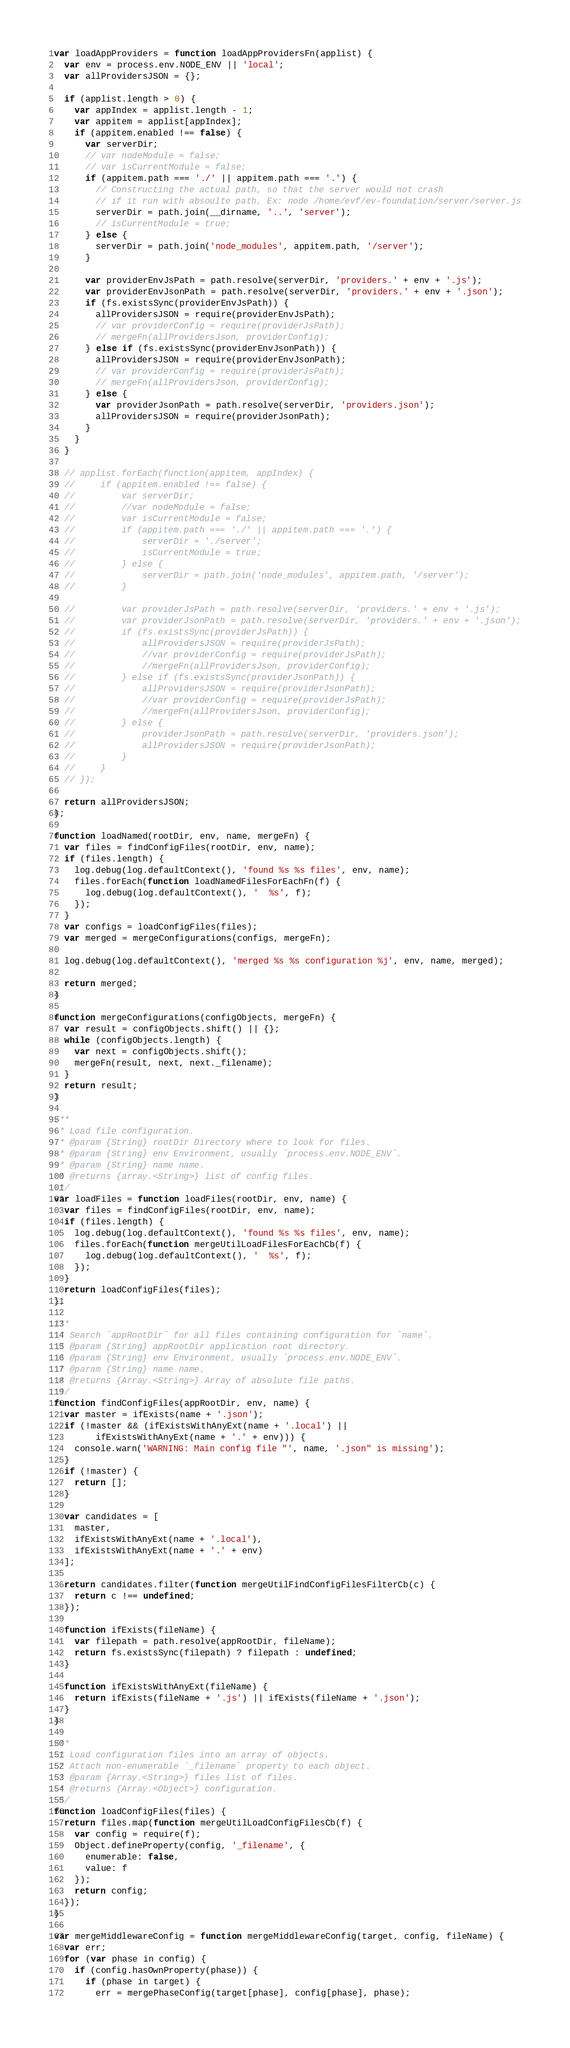Convert code to text. <code><loc_0><loc_0><loc_500><loc_500><_JavaScript_>
var loadAppProviders = function loadAppProvidersFn(applist) {
  var env = process.env.NODE_ENV || 'local';
  var allProvidersJSON = {};

  if (applist.length > 0) {
    var appIndex = applist.length - 1;
    var appitem = applist[appIndex];
    if (appitem.enabled !== false) {
      var serverDir;
      // var nodeModule = false;
      // var isCurrentModule = false;
      if (appitem.path === './' || appitem.path === '.') {
        // Constructing the actual path, so that the server would not crash
        // if it run with absoulte path, Ex: node /home/evf/ev-foundation/server/server.js
        serverDir = path.join(__dirname, '..', 'server');
        // isCurrentModule = true;
      } else {
        serverDir = path.join('node_modules', appitem.path, '/server');
      }

      var providerEnvJsPath = path.resolve(serverDir, 'providers.' + env + '.js');
      var providerEnvJsonPath = path.resolve(serverDir, 'providers.' + env + '.json');
      if (fs.existsSync(providerEnvJsPath)) {
        allProvidersJSON = require(providerEnvJsPath);
        // var providerConfig = require(providerJsPath);
        // mergeFn(allProvidersJson, providerConfig);
      } else if (fs.existsSync(providerEnvJsonPath)) {
        allProvidersJSON = require(providerEnvJsonPath);
        // var providerConfig = require(providerJsPath);
        // mergeFn(allProvidersJson, providerConfig);
      } else {
        var providerJsonPath = path.resolve(serverDir, 'providers.json');
        allProvidersJSON = require(providerJsonPath);
      }
    }
  }

  // applist.forEach(function(appitem, appIndex) {
  //     if (appitem.enabled !== false) {
  //         var serverDir;
  //         //var nodeModule = false;
  //         var isCurrentModule = false;
  //         if (appitem.path === './' || appitem.path === '.') {
  //             serverDir = './server';
  //             isCurrentModule = true;
  //         } else {
  //             serverDir = path.join('node_modules', appitem.path, '/server');
  //         }

  //         var providerJsPath = path.resolve(serverDir, 'providers.' + env + '.js');
  //         var providerJsonPath = path.resolve(serverDir, 'providers.' + env + '.json');
  //         if (fs.existsSync(providerJsPath)) {
  //             allProvidersJSON = require(providerJsPath);
  //             //var providerConfig = require(providerJsPath);
  //             //mergeFn(allProvidersJson, providerConfig);
  //         } else if (fs.existsSync(providerJsonPath)) {
  //             allProvidersJSON = require(providerJsonPath);
  //             //var providerConfig = require(providerJsPath);
  //             //mergeFn(allProvidersJson, providerConfig);
  //         } else {
  //             providerJsonPath = path.resolve(serverDir, 'providers.json');
  //             allProvidersJSON = require(providerJsonPath);
  //         }
  //     }
  // });

  return allProvidersJSON;
};

function loadNamed(rootDir, env, name, mergeFn) {
  var files = findConfigFiles(rootDir, env, name);
  if (files.length) {
    log.debug(log.defaultContext(), 'found %s %s files', env, name);
    files.forEach(function loadNamedFilesForEachFn(f) {
      log.debug(log.defaultContext(), '  %s', f);
    });
  }
  var configs = loadConfigFiles(files);
  var merged = mergeConfigurations(configs, mergeFn);

  log.debug(log.defaultContext(), 'merged %s %s configuration %j', env, name, merged);

  return merged;
}

function mergeConfigurations(configObjects, mergeFn) {
  var result = configObjects.shift() || {};
  while (configObjects.length) {
    var next = configObjects.shift();
    mergeFn(result, next, next._filename);
  }
  return result;
}

/**
 * Load file configuration.
 * @param {String} rootDir Directory where to look for files.
 * @param {String} env Environment, usually `process.env.NODE_ENV`.
 * @param {String} name name.
 * @returns {array.<String>} list of config files.
 */
var loadFiles = function loadFiles(rootDir, env, name) {
  var files = findConfigFiles(rootDir, env, name);
  if (files.length) {
    log.debug(log.defaultContext(), 'found %s %s files', env, name);
    files.forEach(function mergeUtilLoadFilesForEachCb(f) {
      log.debug(log.defaultContext(), '  %s', f);
    });
  }
  return loadConfigFiles(files);
};

/**
 * Search `appRootDir` for all files containing configuration for `name`.
 * @param {String} appRootDir application root directory.
 * @param {String} env Environment, usually `process.env.NODE_ENV`.
 * @param {String} name name.
 * @returns {Array.<String>} Array of absolute file paths.
 */
function findConfigFiles(appRootDir, env, name) {
  var master = ifExists(name + '.json');
  if (!master && (ifExistsWithAnyExt(name + '.local') ||
        ifExistsWithAnyExt(name + '.' + env))) {
    console.warn('WARNING: Main config file "', name, '.json" is missing');
  }
  if (!master) {
    return [];
  }

  var candidates = [
    master,
    ifExistsWithAnyExt(name + '.local'),
    ifExistsWithAnyExt(name + '.' + env)
  ];

  return candidates.filter(function mergeUtilFindConfigFilesFilterCb(c) {
    return c !== undefined;
  });

  function ifExists(fileName) {
    var filepath = path.resolve(appRootDir, fileName);
    return fs.existsSync(filepath) ? filepath : undefined;
  }

  function ifExistsWithAnyExt(fileName) {
    return ifExists(fileName + '.js') || ifExists(fileName + '.json');
  }
}

/**
 * Load configuration files into an array of objects.
 * Attach non-enumerable `_filename` property to each object.
 * @param {Array.<String>} files list of files.
 * @returns {Array.<Object>} configuration.
 */
function loadConfigFiles(files) {
  return files.map(function mergeUtilLoadConfigFilesCb(f) {
    var config = require(f);
    Object.defineProperty(config, '_filename', {
      enumerable: false,
      value: f
    });
    return config;
  });
}

var mergeMiddlewareConfig = function mergeMiddlewareConfig(target, config, fileName) {
  var err;
  for (var phase in config) {
    if (config.hasOwnProperty(phase)) {
      if (phase in target) {
        err = mergePhaseConfig(target[phase], config[phase], phase);</code> 